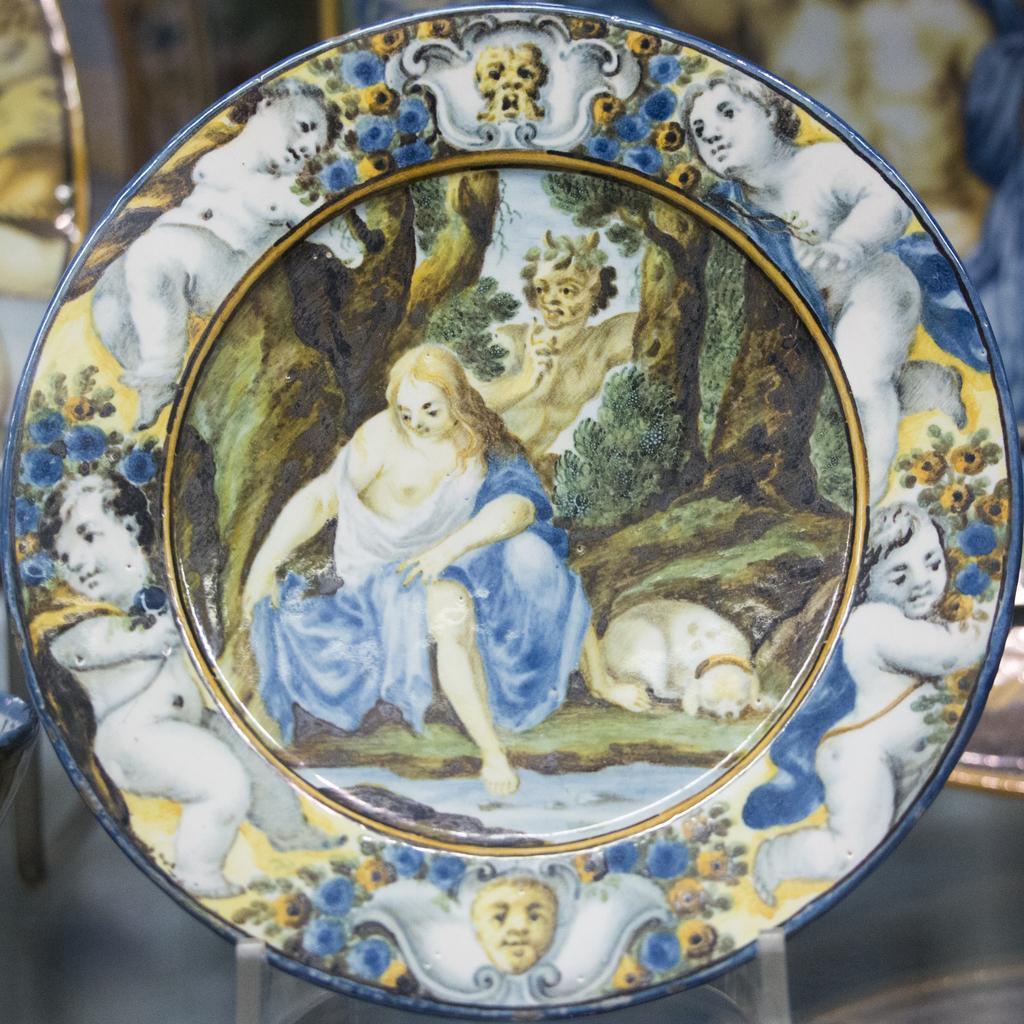How would you summarize this image in a sentence or two? In this picture we can see a decorated plate and behind the plate there are some blurred objects. 